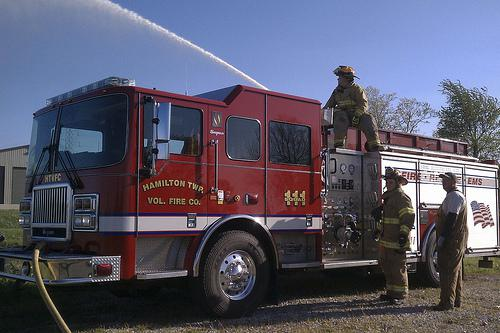Question: what color is the sky?
Choices:
A. White.
B. Gray.
C. Black.
D. Blue.
Answer with the letter. Answer: D Question: how many people are shown?
Choices:
A. One.
B. Three.
C. Six.
D. Four.
Answer with the letter. Answer: B Question: what type of truck is shown?
Choices:
A. Firetruck.
B. Tow truck.
C. Tank truck.
D. Refrigerated truck.
Answer with the letter. Answer: A Question: where was the photo taken?
Choices:
A. On the street.
B. On the sidewalk.
C. On a dirt road.
D. On a hiking trail.
Answer with the letter. Answer: A 